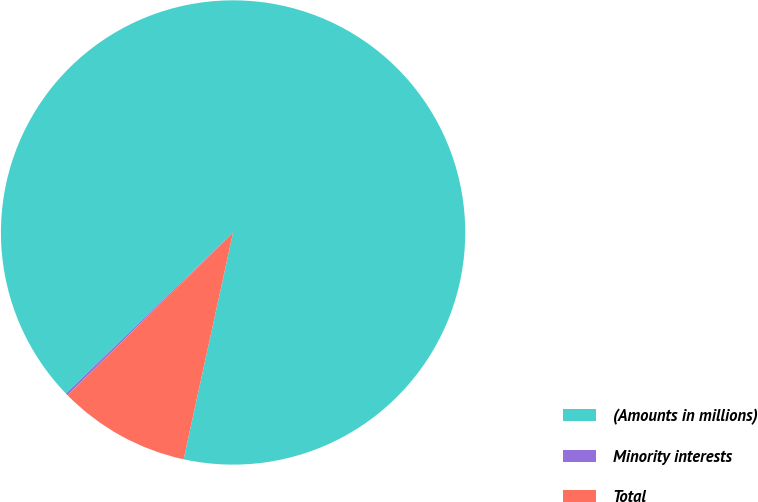<chart> <loc_0><loc_0><loc_500><loc_500><pie_chart><fcel>(Amounts in millions)<fcel>Minority interests<fcel>Total<nl><fcel>90.62%<fcel>0.17%<fcel>9.21%<nl></chart> 